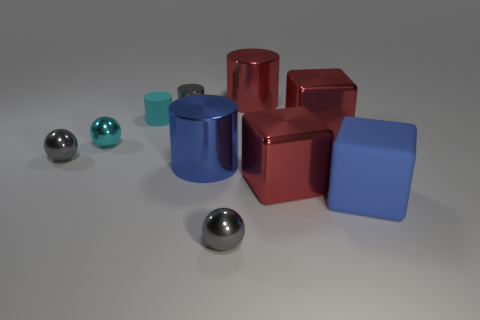How big is the sphere that is in front of the large blue rubber thing?
Offer a very short reply. Small. Is the small matte thing the same shape as the large matte thing?
Provide a short and direct response. No. What number of tiny objects are either cyan matte objects or cylinders?
Ensure brevity in your answer.  2. There is a blue shiny cylinder; are there any tiny spheres to the left of it?
Provide a short and direct response. Yes. Are there the same number of cyan matte cylinders in front of the red cylinder and cyan matte cylinders?
Provide a succinct answer. Yes. There is a red object that is the same shape as the cyan matte thing; what is its size?
Keep it short and to the point. Large. Does the big blue matte object have the same shape as the blue object left of the red cylinder?
Your response must be concise. No. There is a blue object that is behind the large rubber cube to the right of the cyan cylinder; what is its size?
Keep it short and to the point. Large. Are there the same number of things behind the matte cube and big blue cylinders behind the gray shiny cylinder?
Make the answer very short. No. What color is the small shiny object that is the same shape as the tiny rubber object?
Your response must be concise. Gray. 